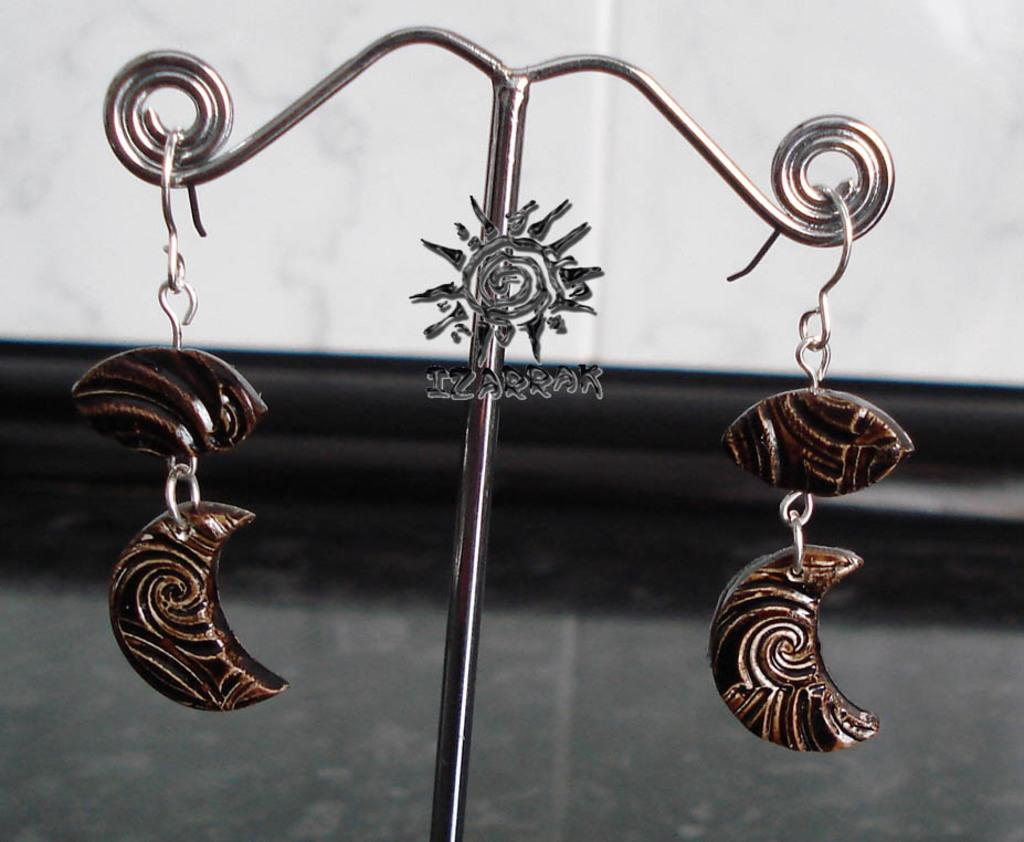What is the main object in the center of the image? There is a pole in the center of the image. What type of accessory can be seen in the image? There is a pair of earrings in the image. What can be seen in the background of the image? There is a wall in the background of the image. How many buns are being used to measure the length of the pole in the image? There are no buns present in the image, and they are not being used to measure the length of the pole. 